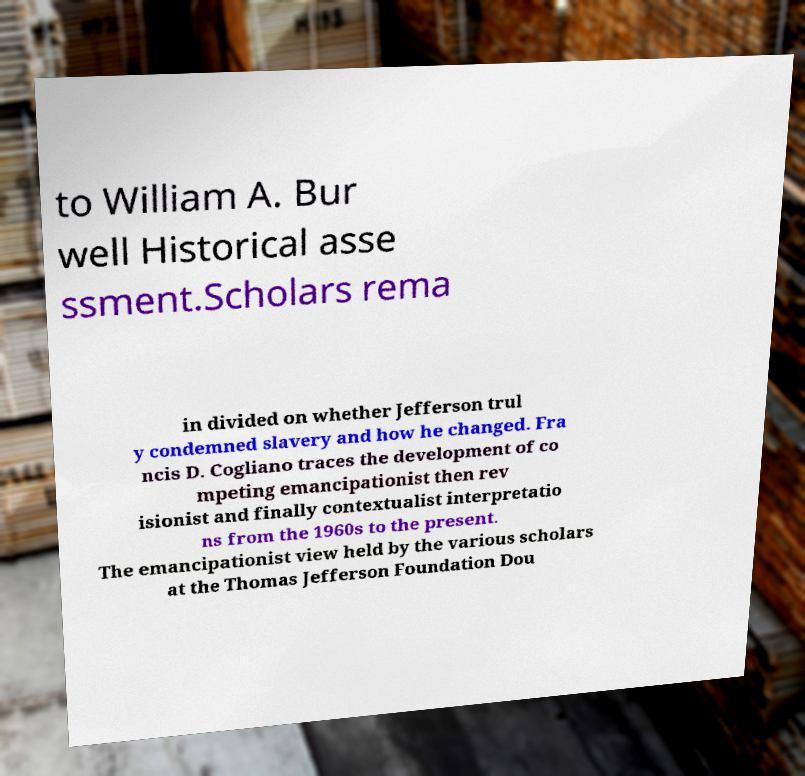Could you extract and type out the text from this image? to William A. Bur well Historical asse ssment.Scholars rema in divided on whether Jefferson trul y condemned slavery and how he changed. Fra ncis D. Cogliano traces the development of co mpeting emancipationist then rev isionist and finally contextualist interpretatio ns from the 1960s to the present. The emancipationist view held by the various scholars at the Thomas Jefferson Foundation Dou 